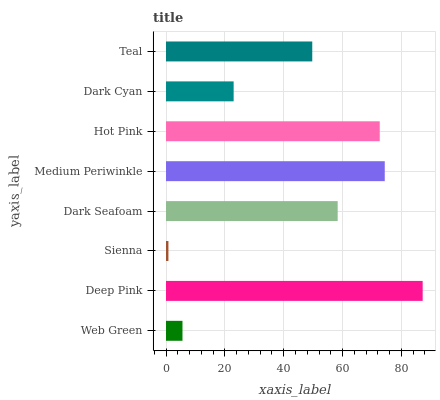Is Sienna the minimum?
Answer yes or no. Yes. Is Deep Pink the maximum?
Answer yes or no. Yes. Is Deep Pink the minimum?
Answer yes or no. No. Is Sienna the maximum?
Answer yes or no. No. Is Deep Pink greater than Sienna?
Answer yes or no. Yes. Is Sienna less than Deep Pink?
Answer yes or no. Yes. Is Sienna greater than Deep Pink?
Answer yes or no. No. Is Deep Pink less than Sienna?
Answer yes or no. No. Is Dark Seafoam the high median?
Answer yes or no. Yes. Is Teal the low median?
Answer yes or no. Yes. Is Sienna the high median?
Answer yes or no. No. Is Medium Periwinkle the low median?
Answer yes or no. No. 